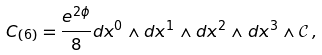Convert formula to latex. <formula><loc_0><loc_0><loc_500><loc_500>C _ { ( 6 ) } = \frac { e ^ { 2 \phi } } { 8 } d x ^ { 0 } \wedge d x ^ { 1 } \wedge d x ^ { 2 } \wedge d x ^ { 3 } \wedge \mathcal { C } \, ,</formula> 